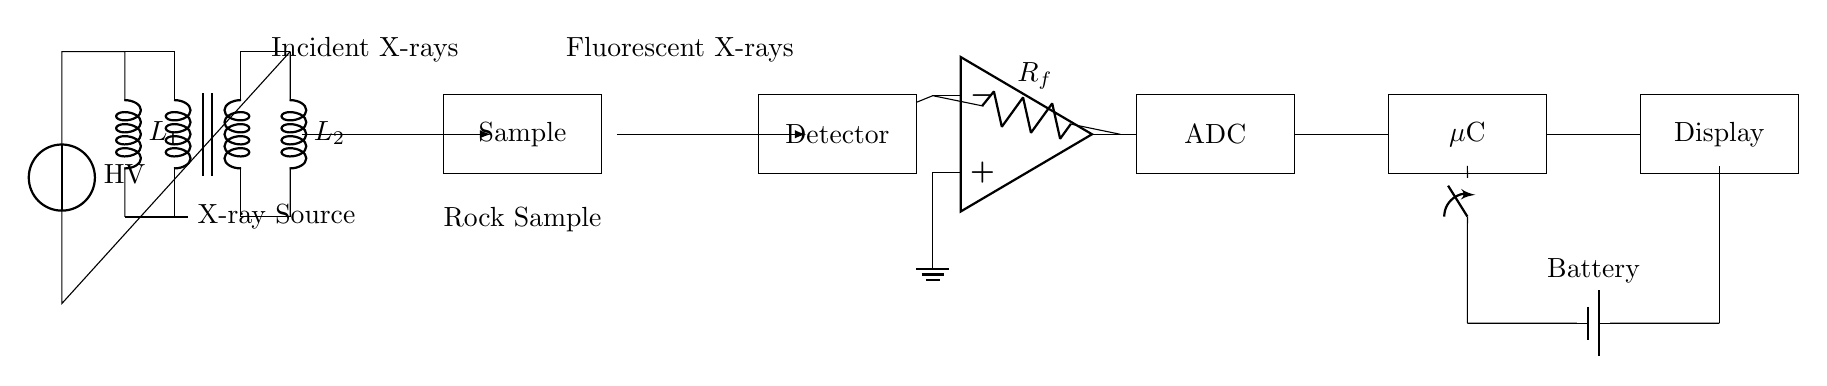What is the main purpose of this circuit? The main purpose of the circuit is to analyze rock samples by measuring the elemental composition using X-ray fluorescence. The components are designed to generate X-rays, expose the sample, detect the emitted fluorescence, and process the signal.
Answer: Element analysis What type of source is used for X-ray generation? The circuit uses a high voltage source to drive two inductors that create an X-ray source. The transformer core indicates that it is a specialized setup for this purpose.
Answer: Transformer What component is used to amplify the detected signal? The operational amplifier marked as Op Amp is used to amplify the signal from the detector before it is sent to the ADC for digitization.
Answer: Op Amp How many main blocks are present in the circuit? There are five main blocks in the circuit: X-ray Source, Sample Holder, Detector, ADC, and Microcontroller. Each block plays a critical role in the functioning of the spectrometer.
Answer: Five What role does the ADC play in this circuit? The ADC converts the amplified analog signal from the Op Amp into a digital signal, which can then be processed by the microcontroller for display or analysis.
Answer: Conversion to digital What does the display do in this circuit setup? The display shows the processed results from the microcontroller, allowing users to view the elemental analysis of the rock samples in real-time.
Answer: Results visualization 